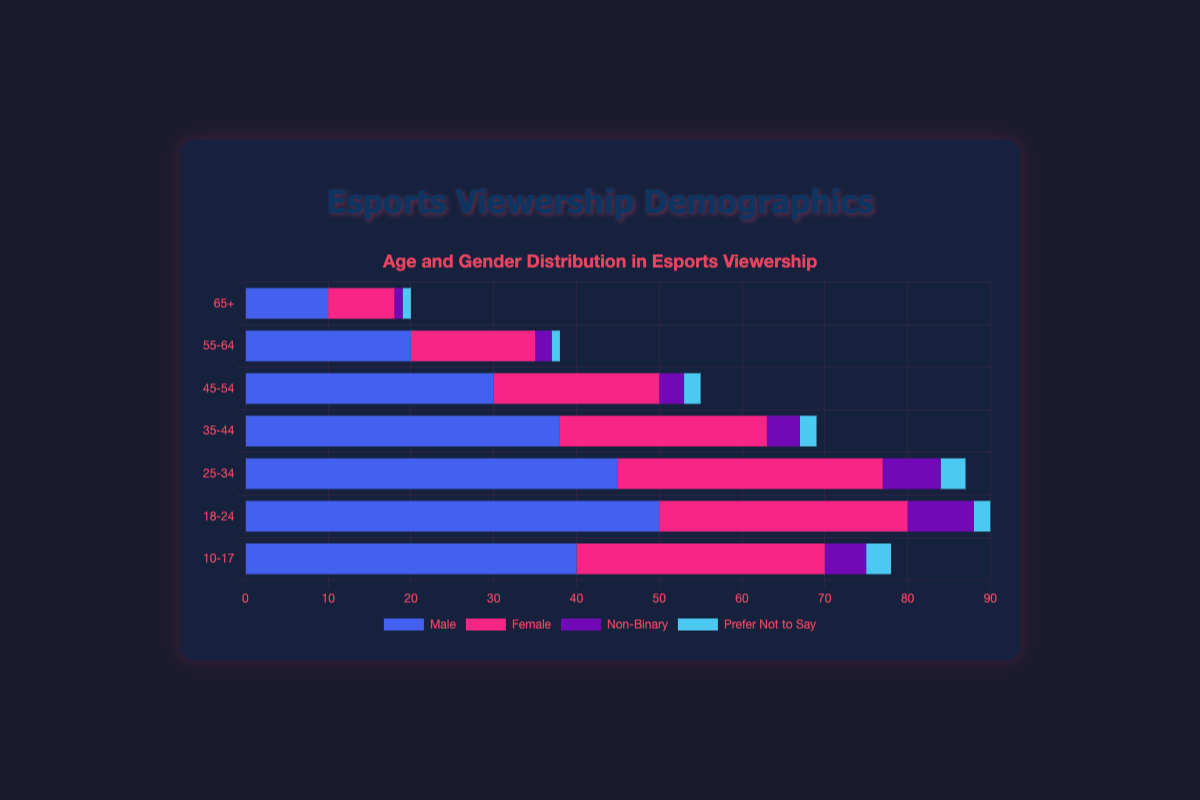What is the total number of esports viewers in the 18-24 age range? To find the total number of viewers in the 18-24 age range, sum up the number of Male, Female, Non-Binary, and Prefer Not to Say viewers: 50 (Male) + 30 (Female) + 8 (Non-Binary) + 2 (Prefer Not to Say) = 90
Answer: 90 Among the "65+" age group, which gender has the least number of viewers? Among the "65+" age group, the breakdown is 10 (Male), 8 (Female), 1 (Non-Binary), 1 (Prefer Not to Say). Non-Binary and Prefer Not to Say both have the least number of viewers with 1 each.
Answer: Non-Binary and Prefer Not to Say Which age range has the highest number of Female viewers? By comparing the number of Female viewers across age ranges, the highest number is 32 in the 25-34 age range.
Answer: 25-34 How does the number of Male viewers in the 35-44 age range compare to the total number of viewers in the 45-54 age range? The number of Male viewers in the 35-44 age range is 38. The total number of viewers in the 45-54 age range is the sum of Male, Female, Non-Binary, and Prefer Not to Say: 30 + 20 + 3 + 2 = 55.
Answer: Less Which category (Male, Female, Non-Binary, Prefer Not to Say) in the 10-17 age range has the second highest number of viewers? The breakdown for the 10-17 age range is 40 (Male), 30 (Female), 5 (Non-Binary), 3 (Prefer Not to Say). The second highest number of viewers is Female with 30.
Answer: Female What is the total number of viewers who are Non-Binary across all age ranges? Sum the number of Non-Binary viewers across all age ranges: 5 (10-17) + 8 (18-24) + 7 (25-34) + 4 (35-44) + 3 (45-54) + 2 (55-64) + 1 (65+) = 30
Answer: 30 In the 18-24 age range, how do the number of Male viewers compare to the number of Female viewers? The number of Male viewers in the 18-24 age range is 50, while the number of Female viewers is 30. Male viewers are 20 more than Female viewers.
Answer: 20 more Considering viewers who Prefer Not to Say their gender, which age range has the most viewers in this category, and how many are there? For viewers who Prefer Not to Say their gender, compare the numbers across age ranges: 3 (10-17), 2 (18-24), 3 (25-34), 2 (35-44), 2 (45-54), 1 (55-64), 1 (65+). The highest number is in the 10-17 and 25-34 age ranges, both with 3 viewers each.
Answer: 10-17 and 25-34, 3 each What visual features distinguish the data points for Male viewers in the figure? The Male viewers' data points are represented by bars with blue color across all age ranges.
Answer: Blue bars Compare the total number of viewers in the 35-44 age range to the total number in the 55-64 age range. Which is greater, and by how much? Sum the total viewers in the 35-44 age range: 38 (Male) + 25 (Female) + 4 (Non-Binary) + 2 (Prefer Not to Say) = 69. Sum the total viewers in the 55-64 age range: 20 (Male) + 15 (Female) + 2 (Non-Binary) + 1 (Prefer Not to Say) = 38. The difference is 69 - 38 = 31.
Answer: 35-44, by 31 